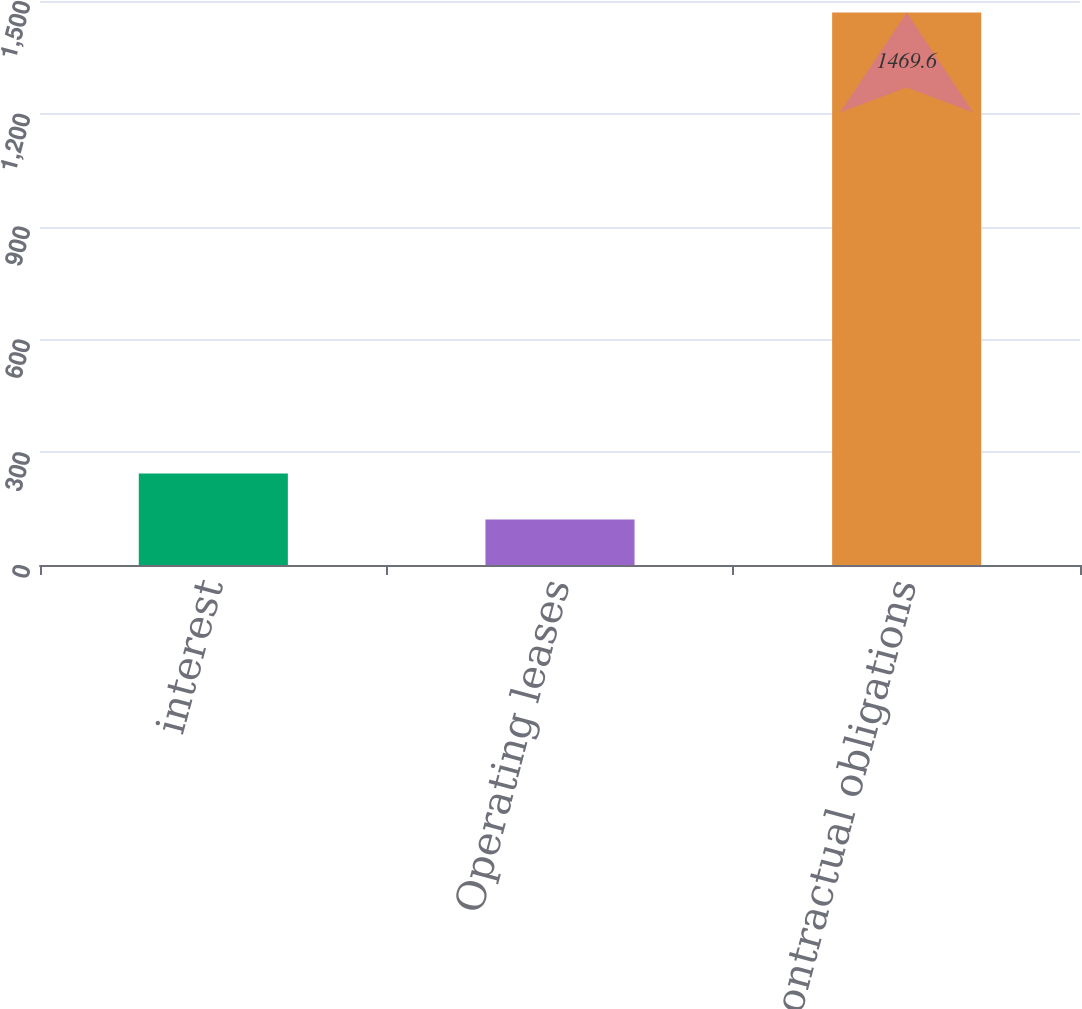Convert chart to OTSL. <chart><loc_0><loc_0><loc_500><loc_500><bar_chart><fcel>interest<fcel>Operating leases<fcel>Total contractual obligations<nl><fcel>243.6<fcel>121<fcel>1469.6<nl></chart> 